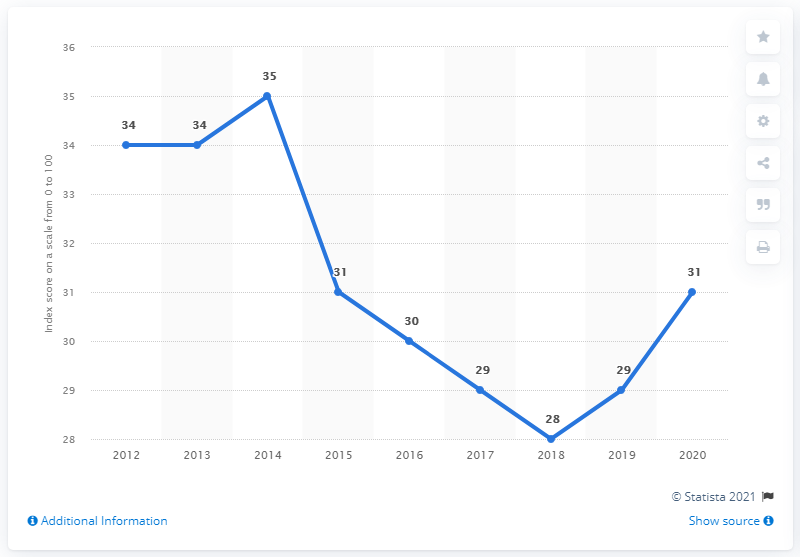Point out several critical features in this image. In 2019, the corruption perception index score was 29. In 2020, Mexico's corruption perception index score was 31, indicating a high level of corruption in the country. 